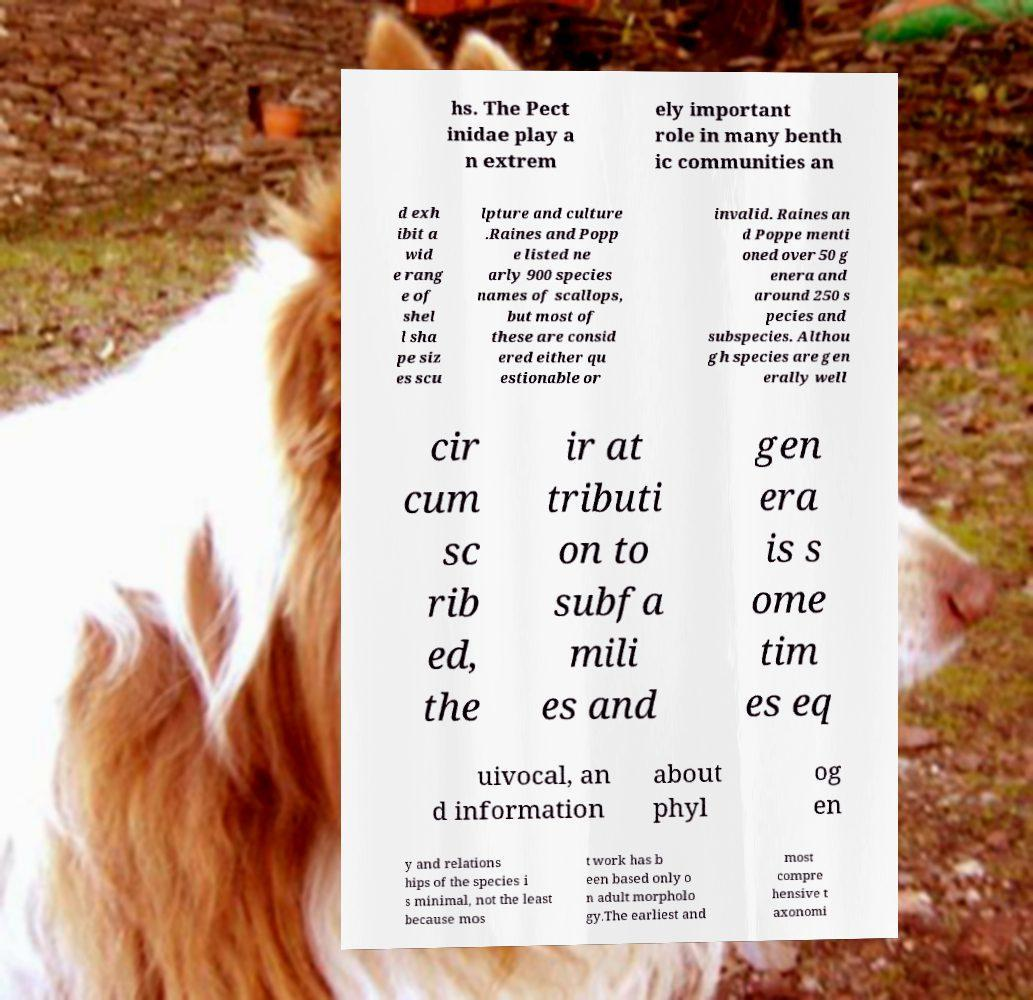I need the written content from this picture converted into text. Can you do that? hs. The Pect inidae play a n extrem ely important role in many benth ic communities an d exh ibit a wid e rang e of shel l sha pe siz es scu lpture and culture .Raines and Popp e listed ne arly 900 species names of scallops, but most of these are consid ered either qu estionable or invalid. Raines an d Poppe menti oned over 50 g enera and around 250 s pecies and subspecies. Althou gh species are gen erally well cir cum sc rib ed, the ir at tributi on to subfa mili es and gen era is s ome tim es eq uivocal, an d information about phyl og en y and relations hips of the species i s minimal, not the least because mos t work has b een based only o n adult morpholo gy.The earliest and most compre hensive t axonomi 